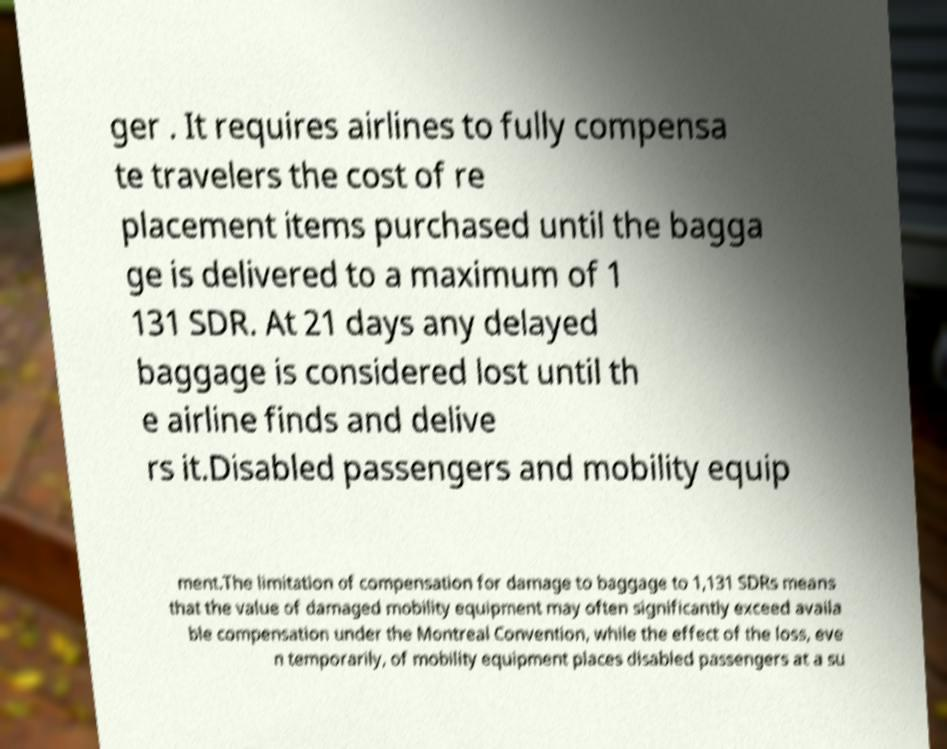Could you extract and type out the text from this image? ger . It requires airlines to fully compensa te travelers the cost of re placement items purchased until the bagga ge is delivered to a maximum of 1 131 SDR. At 21 days any delayed baggage is considered lost until th e airline finds and delive rs it.Disabled passengers and mobility equip ment.The limitation of compensation for damage to baggage to 1,131 SDRs means that the value of damaged mobility equipment may often significantly exceed availa ble compensation under the Montreal Convention, while the effect of the loss, eve n temporarily, of mobility equipment places disabled passengers at a su 